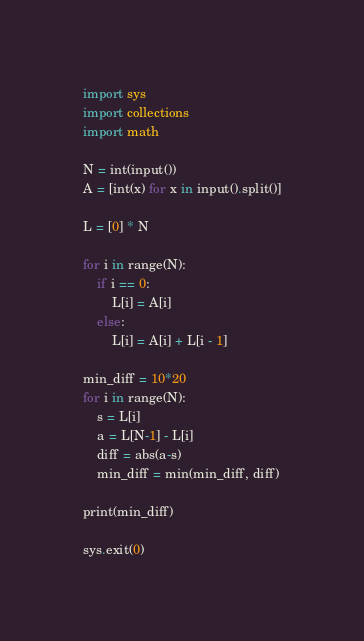Convert code to text. <code><loc_0><loc_0><loc_500><loc_500><_Python_>import sys
import collections
import math

N = int(input())
A = [int(x) for x in input().split()]

L = [0] * N

for i in range(N):
    if i == 0:
        L[i] = A[i]
    else:
        L[i] = A[i] + L[i - 1]

min_diff = 10*20
for i in range(N):
    s = L[i]
    a = L[N-1] - L[i]
    diff = abs(a-s)
    min_diff = min(min_diff, diff)

print(min_diff)

sys.exit(0)
</code> 